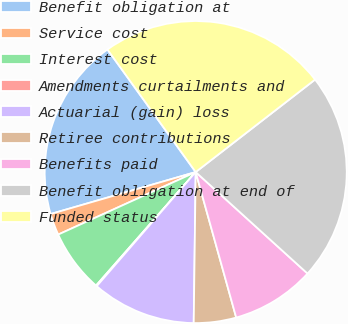Convert chart. <chart><loc_0><loc_0><loc_500><loc_500><pie_chart><fcel>Benefit obligation at<fcel>Service cost<fcel>Interest cost<fcel>Amendments curtailments and<fcel>Actuarial (gain) loss<fcel>Retiree contributions<fcel>Benefits paid<fcel>Benefit obligation at end of<fcel>Funded status<nl><fcel>19.55%<fcel>2.31%<fcel>6.74%<fcel>0.1%<fcel>11.16%<fcel>4.53%<fcel>8.95%<fcel>22.22%<fcel>24.44%<nl></chart> 